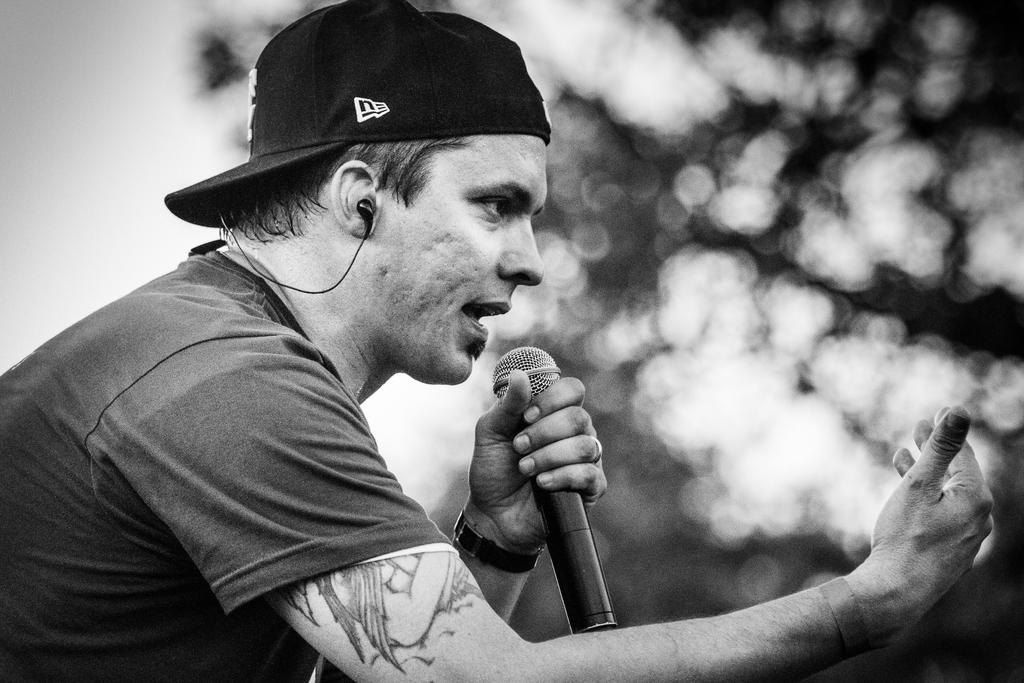What is the main subject of the image? The main subject of the image is a man. What is the man wearing on his head? The man is wearing a cap. What type of clothing is the man wearing on his upper body? The man is wearing a T-shirt. What object is the man holding in the image? The man is holding a microphone. What is the man doing in the image? The man is talking. What can be seen in the background of the image? There are trees in the background of the image. What type of comb can be seen in the man's hair in the image? There is no comb visible in the man's hair in the image. What type of berry is the man holding in his hand in the image? The man is not holding any berries in the image; he is holding a microphone. 